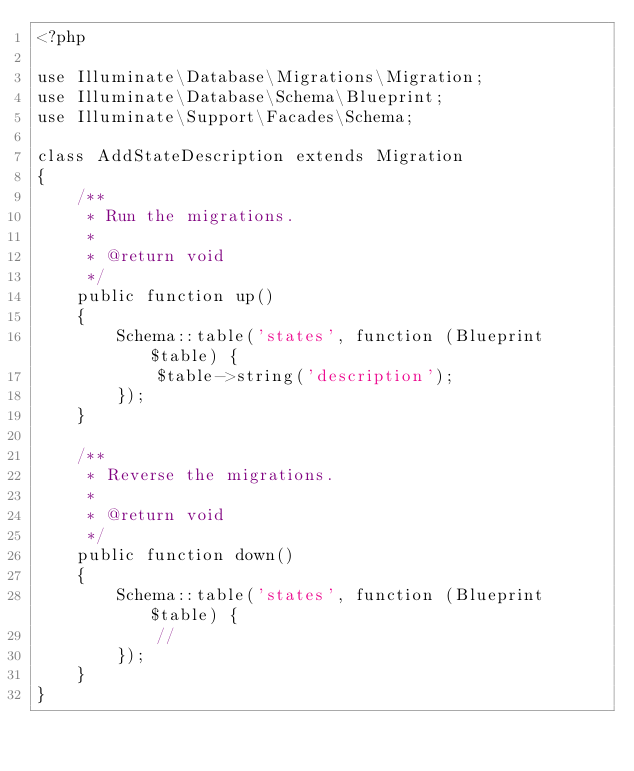<code> <loc_0><loc_0><loc_500><loc_500><_PHP_><?php

use Illuminate\Database\Migrations\Migration;
use Illuminate\Database\Schema\Blueprint;
use Illuminate\Support\Facades\Schema;

class AddStateDescription extends Migration
{
    /**
     * Run the migrations.
     *
     * @return void
     */
    public function up()
    {
        Schema::table('states', function (Blueprint $table) {
            $table->string('description');
        });
    }

    /**
     * Reverse the migrations.
     *
     * @return void
     */
    public function down()
    {
        Schema::table('states', function (Blueprint $table) {
            //
        });
    }
}
</code> 